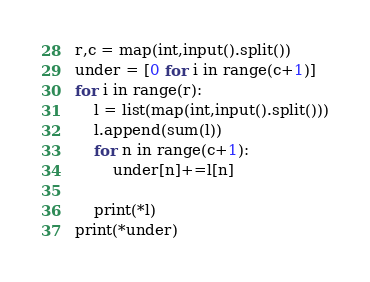<code> <loc_0><loc_0><loc_500><loc_500><_Python_>r,c = map(int,input().split())
under = [0 for i in range(c+1)]
for i in range(r):
    l = list(map(int,input().split()))
    l.append(sum(l))
    for n in range(c+1):
        under[n]+=l[n]

    print(*l)
print(*under)
</code> 